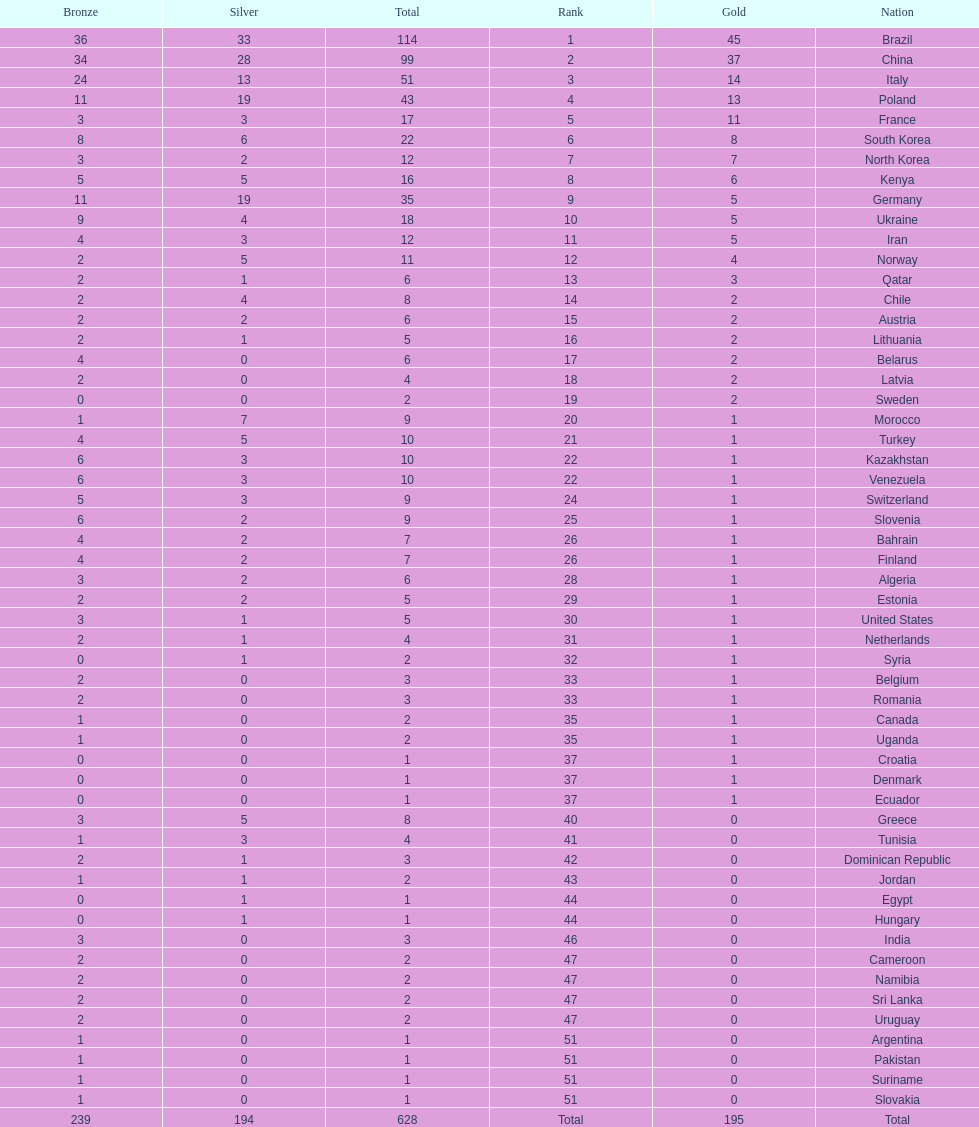How many gold medals did germany earn? 5. 